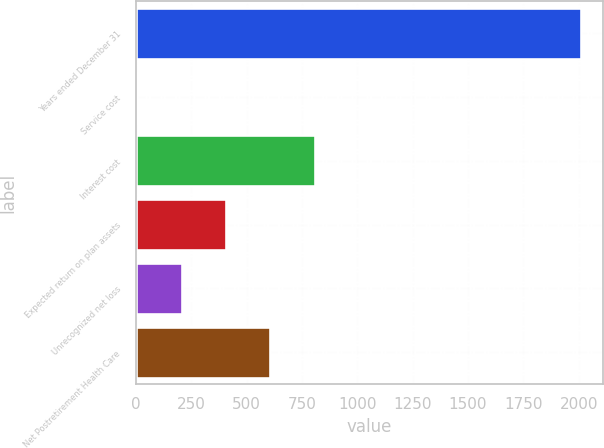<chart> <loc_0><loc_0><loc_500><loc_500><bar_chart><fcel>Years ended December 31<fcel>Service cost<fcel>Interest cost<fcel>Expected return on plan assets<fcel>Unrecognized net loss<fcel>Net Postretirement Health Care<nl><fcel>2010<fcel>6<fcel>807.6<fcel>406.8<fcel>206.4<fcel>607.2<nl></chart> 